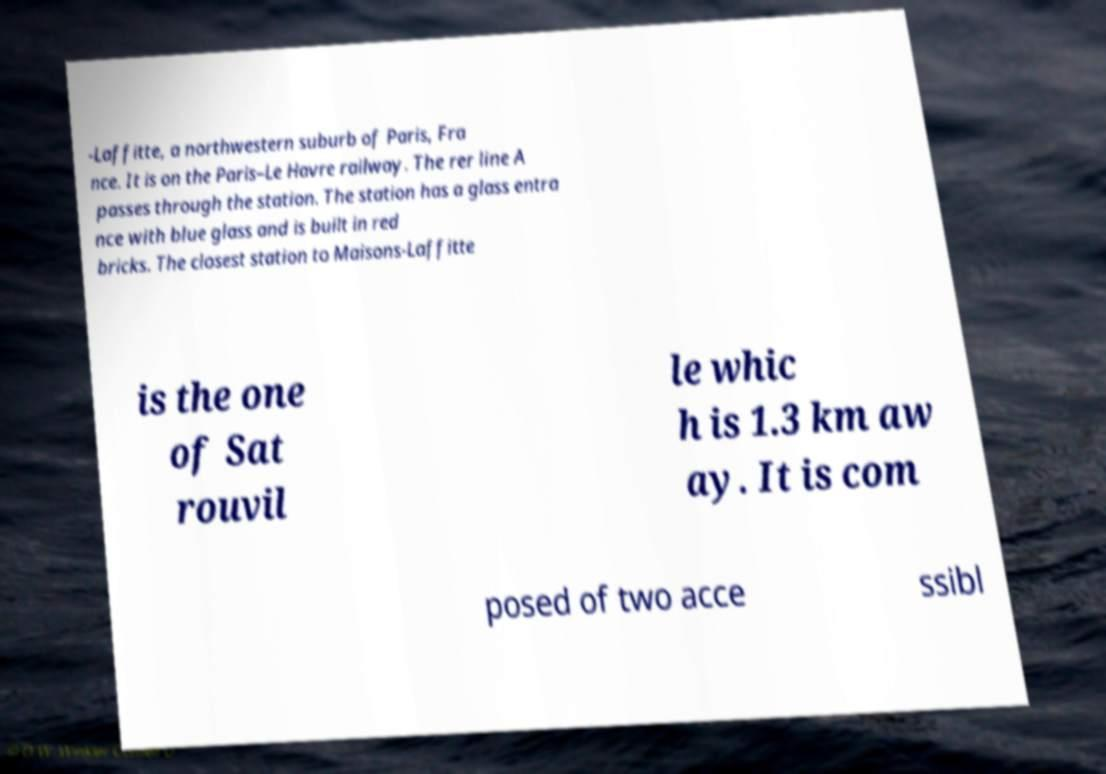For documentation purposes, I need the text within this image transcribed. Could you provide that? -Laffitte, a northwestern suburb of Paris, Fra nce. It is on the Paris–Le Havre railway. The rer line A passes through the station. The station has a glass entra nce with blue glass and is built in red bricks. The closest station to Maisons-Laffitte is the one of Sat rouvil le whic h is 1.3 km aw ay. It is com posed of two acce ssibl 